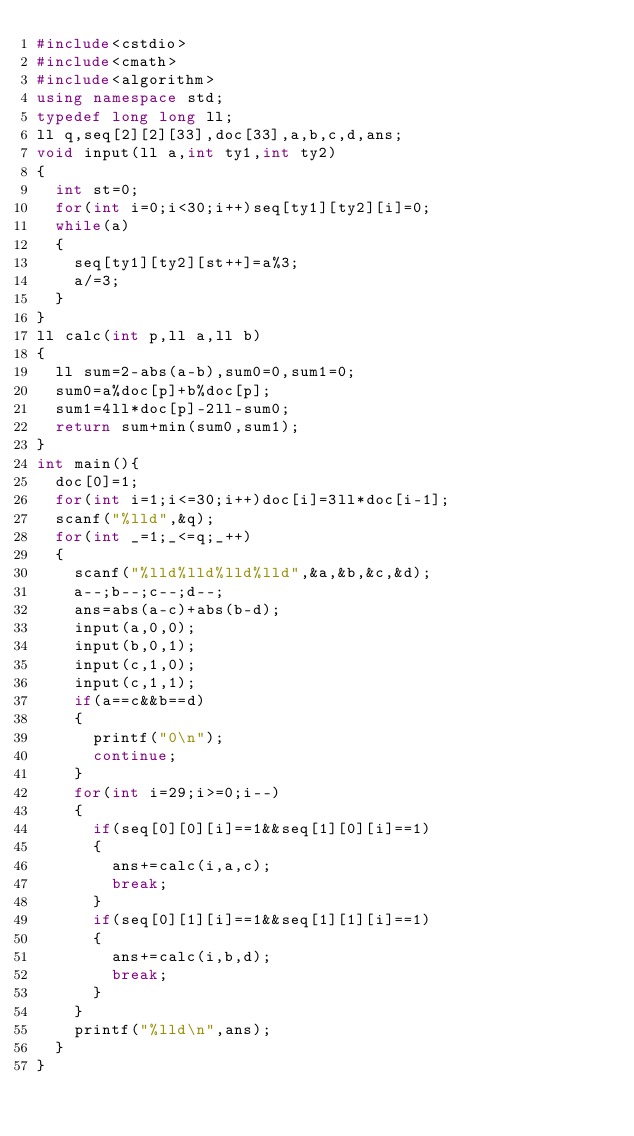Convert code to text. <code><loc_0><loc_0><loc_500><loc_500><_C++_>#include<cstdio>
#include<cmath> 
#include<algorithm>
using namespace std;
typedef long long ll;
ll q,seq[2][2][33],doc[33],a,b,c,d,ans;
void input(ll a,int ty1,int ty2)
{
	int st=0;
	for(int i=0;i<30;i++)seq[ty1][ty2][i]=0;
	while(a)
	{
		seq[ty1][ty2][st++]=a%3;
		a/=3;
	}
}
ll calc(int p,ll a,ll b)
{
	ll sum=2-abs(a-b),sum0=0,sum1=0;
	sum0=a%doc[p]+b%doc[p];
	sum1=4ll*doc[p]-2ll-sum0;
	return sum+min(sum0,sum1);
}
int main(){
	doc[0]=1;
	for(int i=1;i<=30;i++)doc[i]=3ll*doc[i-1];
	scanf("%lld",&q);
	for(int _=1;_<=q;_++)
	{
		scanf("%lld%lld%lld%lld",&a,&b,&c,&d);
		a--;b--;c--;d--;
		ans=abs(a-c)+abs(b-d);
		input(a,0,0);
		input(b,0,1);
		input(c,1,0);
		input(c,1,1);
		if(a==c&&b==d)
		{
			printf("0\n");
			continue;	
		}	
		for(int i=29;i>=0;i--)
		{
			if(seq[0][0][i]==1&&seq[1][0][i]==1)
			{
				ans+=calc(i,a,c);
				break;
			}
			if(seq[0][1][i]==1&&seq[1][1][i]==1)
			{
				ans+=calc(i,b,d);
				break;
			}
		}
		printf("%lld\n",ans);
	}
}</code> 